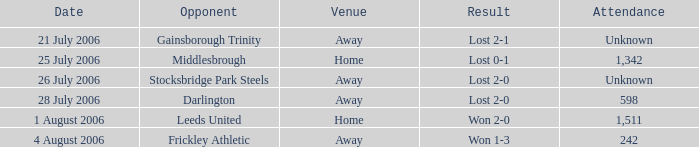Which competitor has undisclosed attendance, and lost 2-0? Stocksbridge Park Steels. 